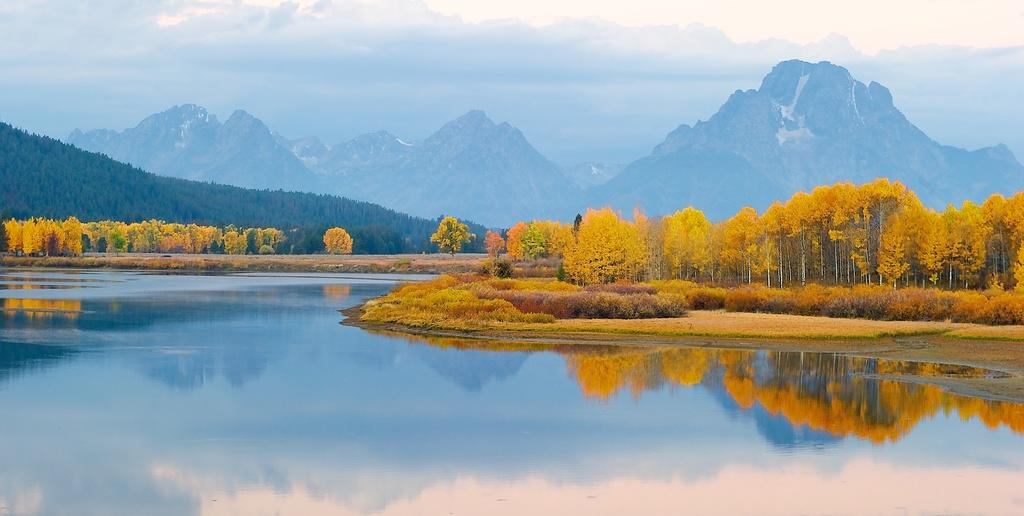What is present at the bottom of the image? There is water at the bottom of the image. What can be seen in the background of the image? There are trees, grass, bushes, and mountains in the background of the image. What is visible at the top of the image? The sky is visible at the top of the image. What type of cord is being used to tie the mountains together in the image? There is no cord present in the image, and the mountains are not tied together. What is the interest of the trees in the background of the image? The trees do not have any interests, as they are inanimate objects. 